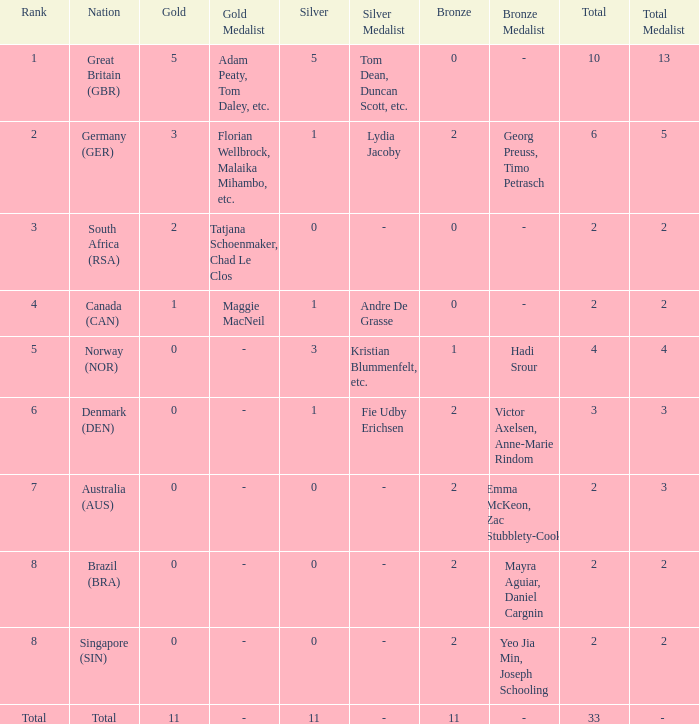What is the least total when the nation is canada (can) and bronze is less than 0? None. 